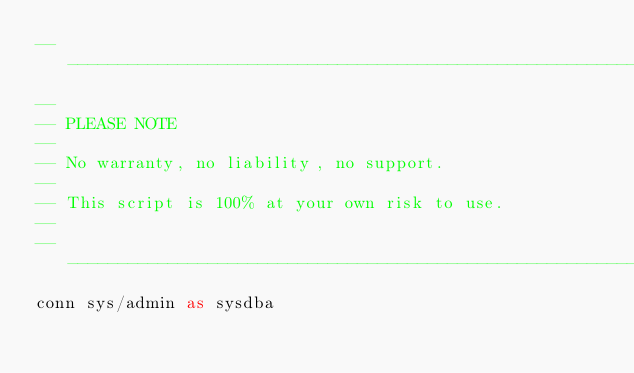Convert code to text. <code><loc_0><loc_0><loc_500><loc_500><_SQL_>-------------------------------------------------------------------------------
--
-- PLEASE NOTE
-- 
-- No warranty, no liability, no support.
--
-- This script is 100% at your own risk to use.
--
-------------------------------------------------------------------------------
conn sys/admin as sysdba
</code> 